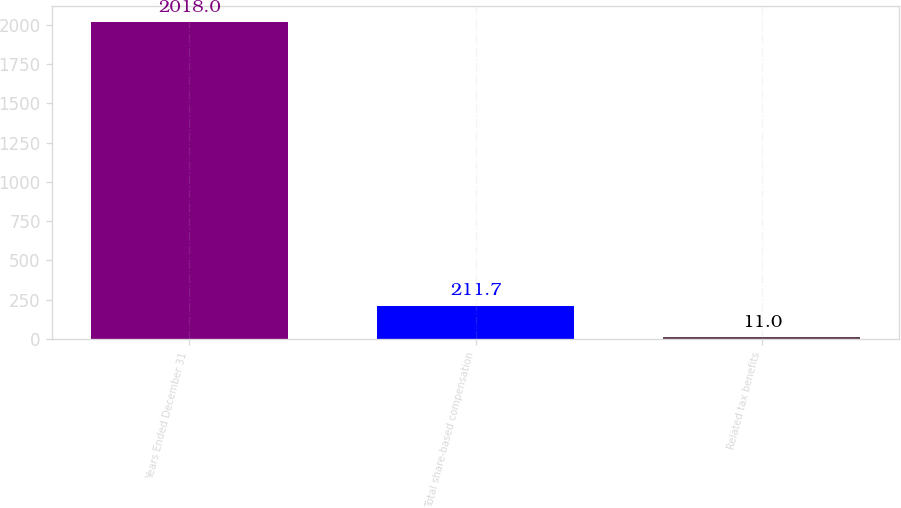Convert chart. <chart><loc_0><loc_0><loc_500><loc_500><bar_chart><fcel>Years Ended December 31<fcel>Total share-based compensation<fcel>Related tax benefits<nl><fcel>2018<fcel>211.7<fcel>11<nl></chart> 